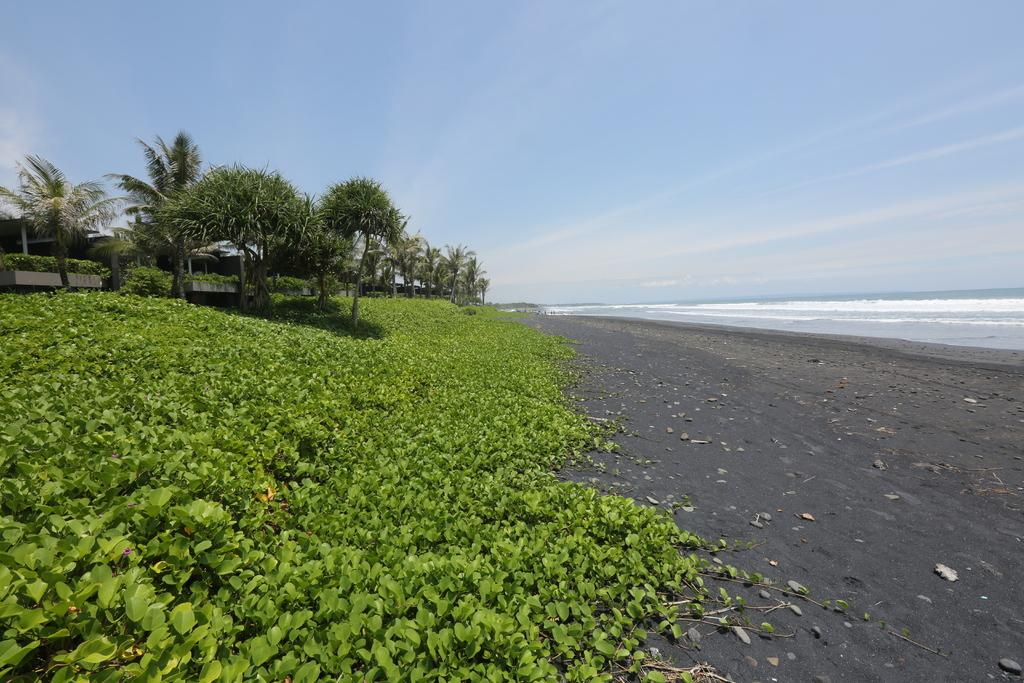What natural feature is the main subject of the picture? There is an ocean in the picture. What type of vegetation is on the left side of the picture? There are trees and grass on the left side of the picture. What is the condition of the sky in the picture? The sky is clear in the picture. Can you see any impulses or smoke coming from the ocean in the picture? No, there is no impulse or smoke visible in the image; it features an ocean, trees, grass, and a clear sky. Is there a rainstorm occurring in the picture? No, there is no rainstorm present in the image; the sky is clear. 